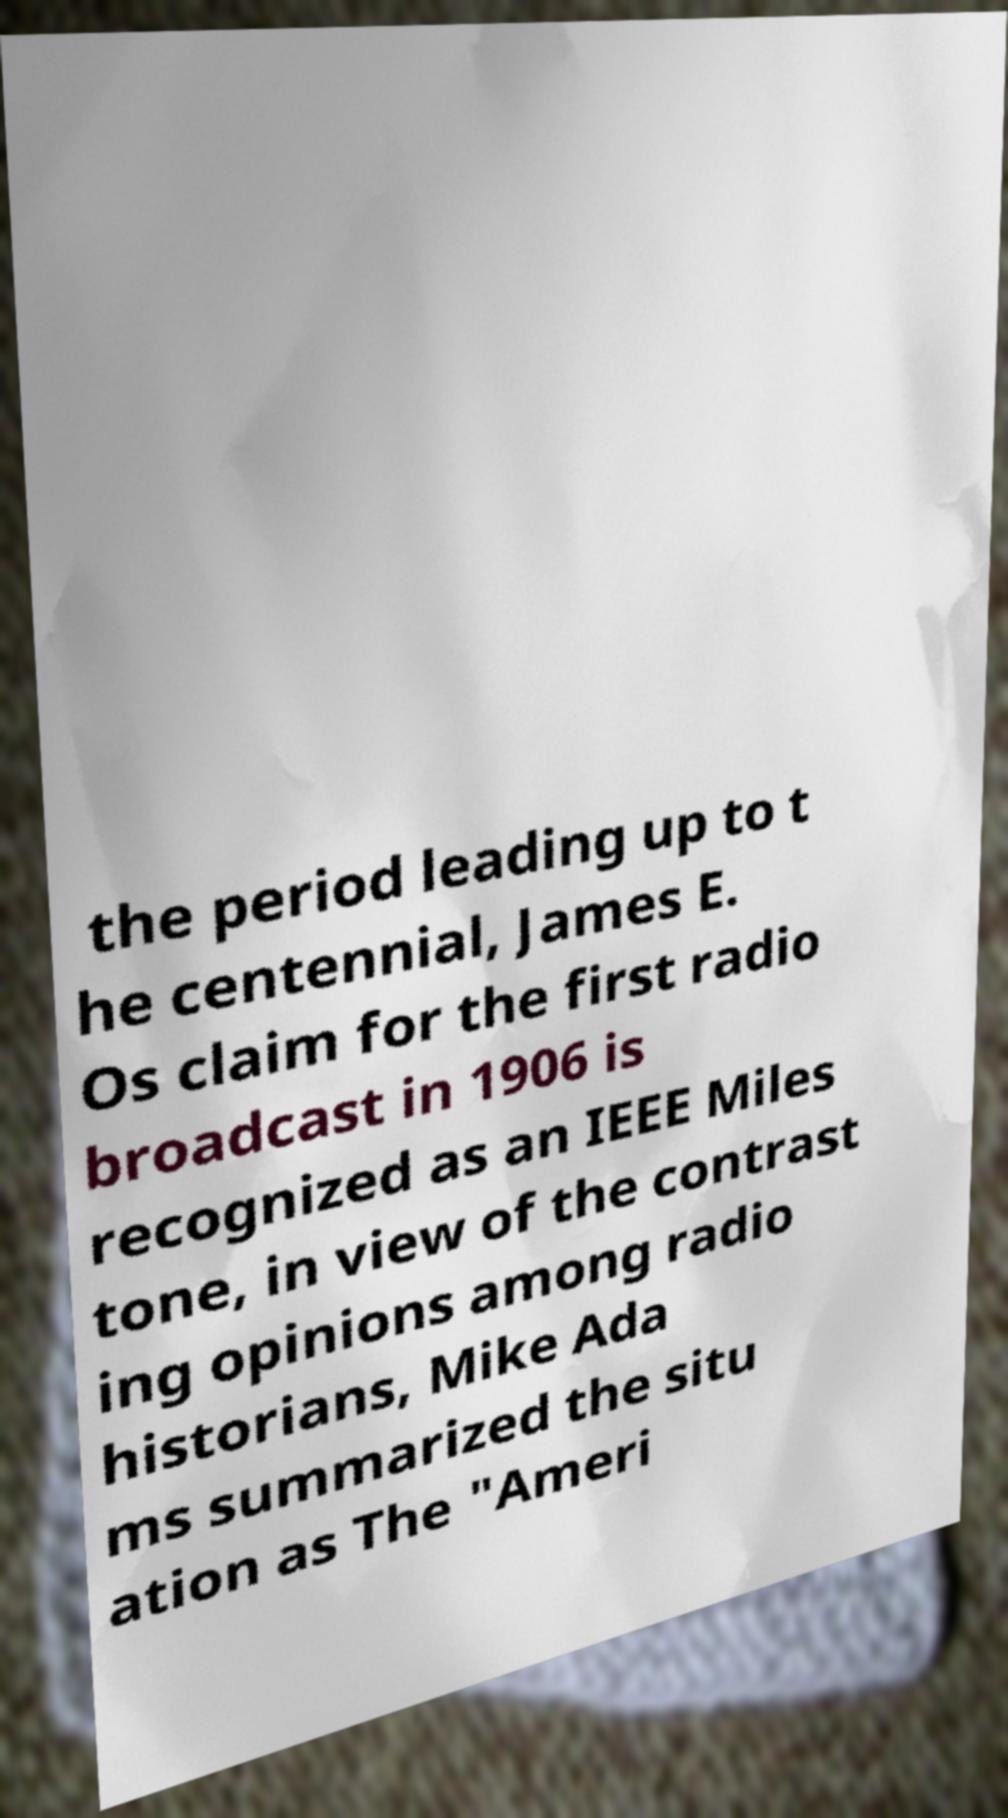Please read and relay the text visible in this image. What does it say? the period leading up to t he centennial, James E. Os claim for the first radio broadcast in 1906 is recognized as an IEEE Miles tone, in view of the contrast ing opinions among radio historians, Mike Ada ms summarized the situ ation as The "Ameri 